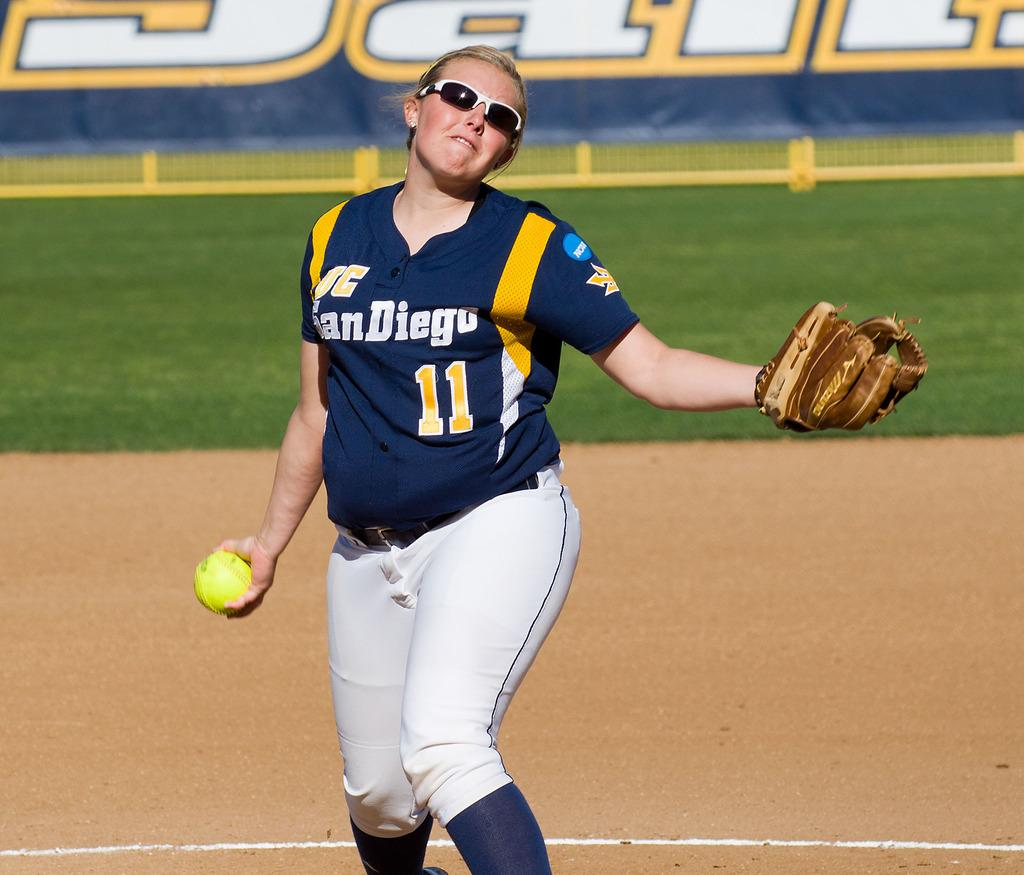<image>
Summarize the visual content of the image. A female baseball player has the number 11 on her t-shirt. 